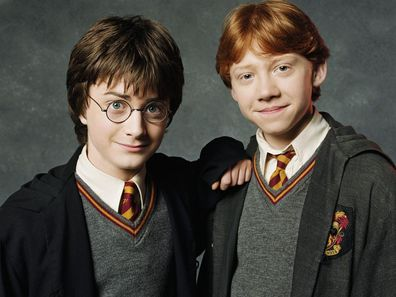Can you tell me a fun fact about these characters? A fun fact about Harry Potter (Daniel Radcliffe) and Ron Weasley (Rupert Grint) is that both characters have a signature treat they love from the wizarding world. Harry enjoys Chocolate Frogs, which come with collectible wizard cards, and Ron loves Bertie Bott's Every Flavour Beans, which include every possible bean flavor, from tasty ones like apple and coconut to bizarre ones like earwax and dirt! 